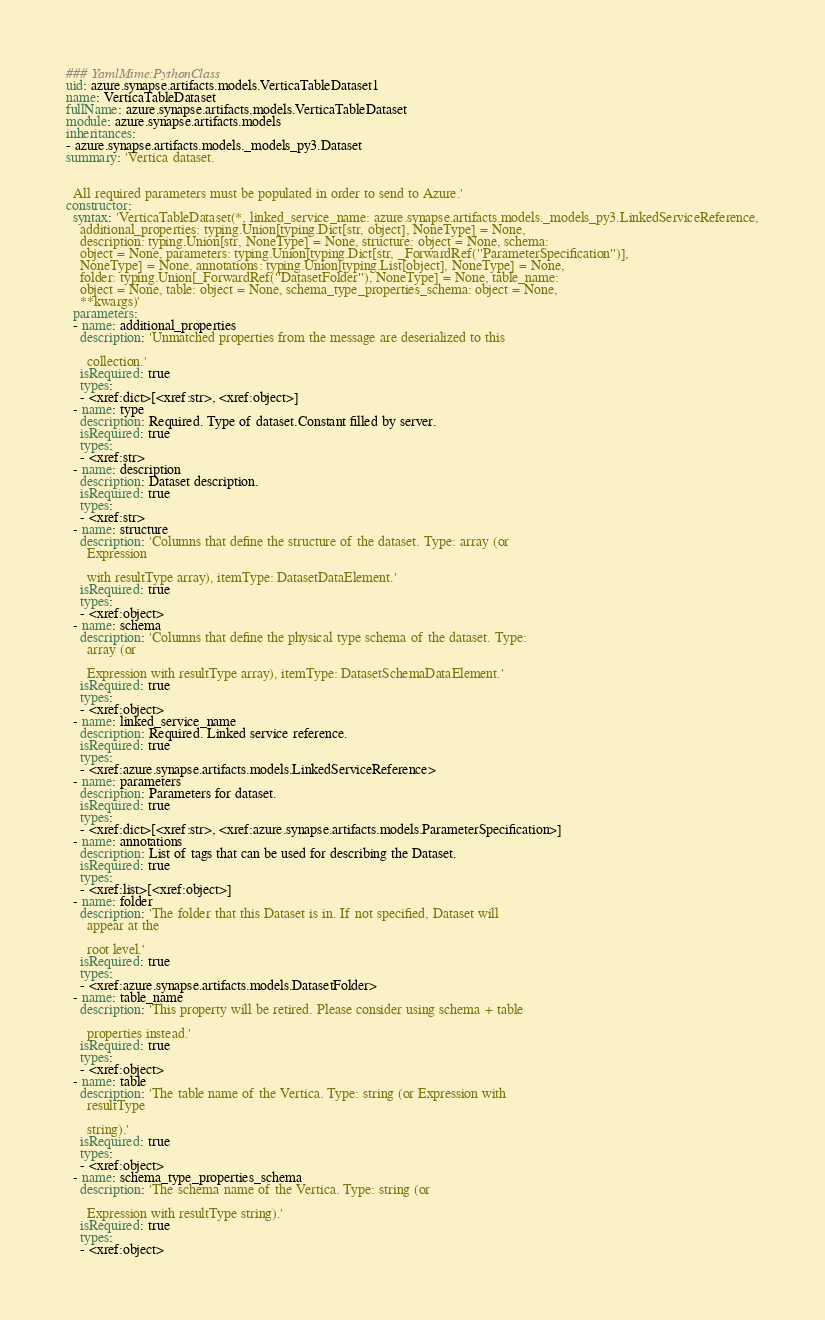Convert code to text. <code><loc_0><loc_0><loc_500><loc_500><_YAML_>### YamlMime:PythonClass
uid: azure.synapse.artifacts.models.VerticaTableDataset1
name: VerticaTableDataset
fullName: azure.synapse.artifacts.models.VerticaTableDataset
module: azure.synapse.artifacts.models
inheritances:
- azure.synapse.artifacts.models._models_py3.Dataset
summary: 'Vertica dataset.


  All required parameters must be populated in order to send to Azure.'
constructor:
  syntax: 'VerticaTableDataset(*, linked_service_name: azure.synapse.artifacts.models._models_py3.LinkedServiceReference,
    additional_properties: typing.Union[typing.Dict[str, object], NoneType] = None,
    description: typing.Union[str, NoneType] = None, structure: object = None, schema:
    object = None, parameters: typing.Union[typing.Dict[str, _ForwardRef(''ParameterSpecification'')],
    NoneType] = None, annotations: typing.Union[typing.List[object], NoneType] = None,
    folder: typing.Union[_ForwardRef(''DatasetFolder''), NoneType] = None, table_name:
    object = None, table: object = None, schema_type_properties_schema: object = None,
    **kwargs)'
  parameters:
  - name: additional_properties
    description: 'Unmatched properties from the message are deserialized to this

      collection.'
    isRequired: true
    types:
    - <xref:dict>[<xref:str>, <xref:object>]
  - name: type
    description: Required. Type of dataset.Constant filled by server.
    isRequired: true
    types:
    - <xref:str>
  - name: description
    description: Dataset description.
    isRequired: true
    types:
    - <xref:str>
  - name: structure
    description: 'Columns that define the structure of the dataset. Type: array (or
      Expression

      with resultType array), itemType: DatasetDataElement.'
    isRequired: true
    types:
    - <xref:object>
  - name: schema
    description: 'Columns that define the physical type schema of the dataset. Type:
      array (or

      Expression with resultType array), itemType: DatasetSchemaDataElement.'
    isRequired: true
    types:
    - <xref:object>
  - name: linked_service_name
    description: Required. Linked service reference.
    isRequired: true
    types:
    - <xref:azure.synapse.artifacts.models.LinkedServiceReference>
  - name: parameters
    description: Parameters for dataset.
    isRequired: true
    types:
    - <xref:dict>[<xref:str>, <xref:azure.synapse.artifacts.models.ParameterSpecification>]
  - name: annotations
    description: List of tags that can be used for describing the Dataset.
    isRequired: true
    types:
    - <xref:list>[<xref:object>]
  - name: folder
    description: 'The folder that this Dataset is in. If not specified, Dataset will
      appear at the

      root level.'
    isRequired: true
    types:
    - <xref:azure.synapse.artifacts.models.DatasetFolder>
  - name: table_name
    description: 'This property will be retired. Please consider using schema + table

      properties instead.'
    isRequired: true
    types:
    - <xref:object>
  - name: table
    description: 'The table name of the Vertica. Type: string (or Expression with
      resultType

      string).'
    isRequired: true
    types:
    - <xref:object>
  - name: schema_type_properties_schema
    description: 'The schema name of the Vertica. Type: string (or

      Expression with resultType string).'
    isRequired: true
    types:
    - <xref:object>
</code> 